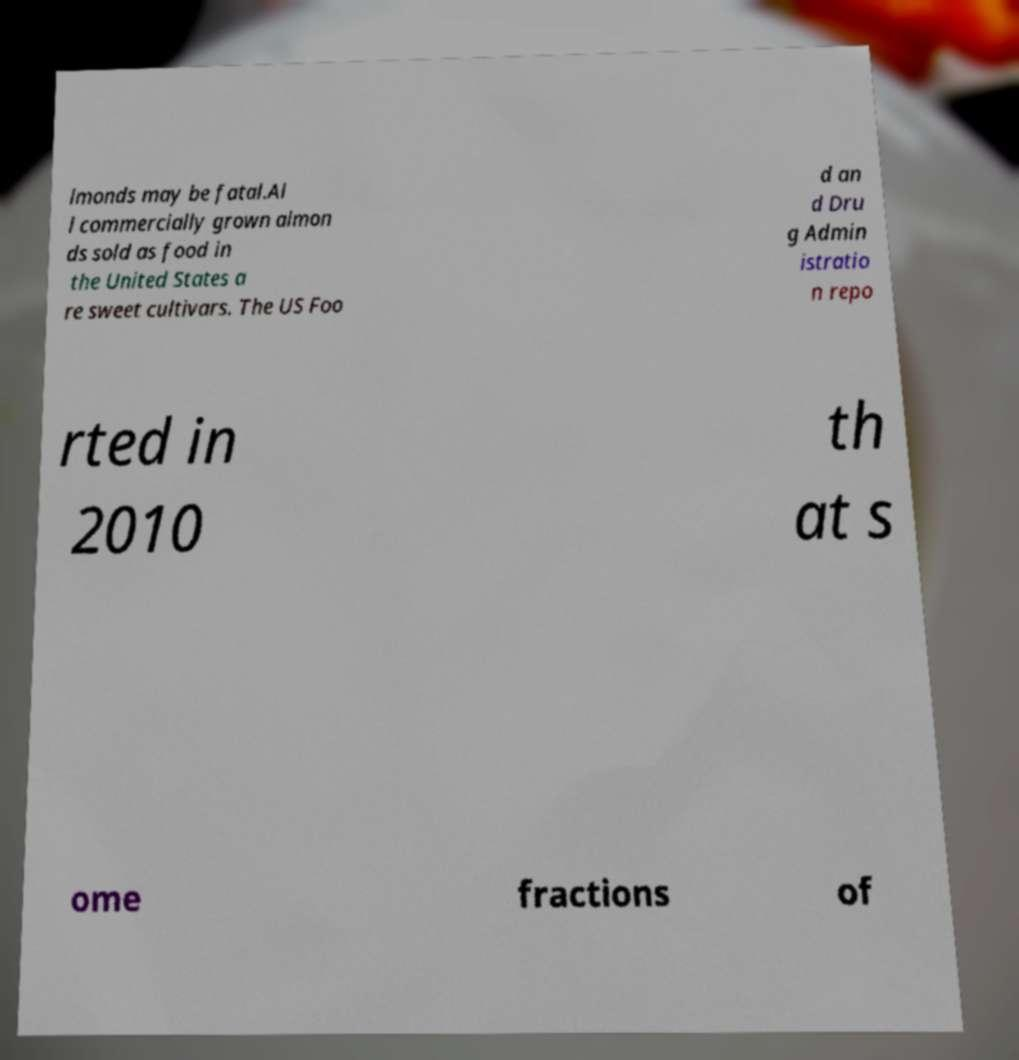For documentation purposes, I need the text within this image transcribed. Could you provide that? lmonds may be fatal.Al l commercially grown almon ds sold as food in the United States a re sweet cultivars. The US Foo d an d Dru g Admin istratio n repo rted in 2010 th at s ome fractions of 